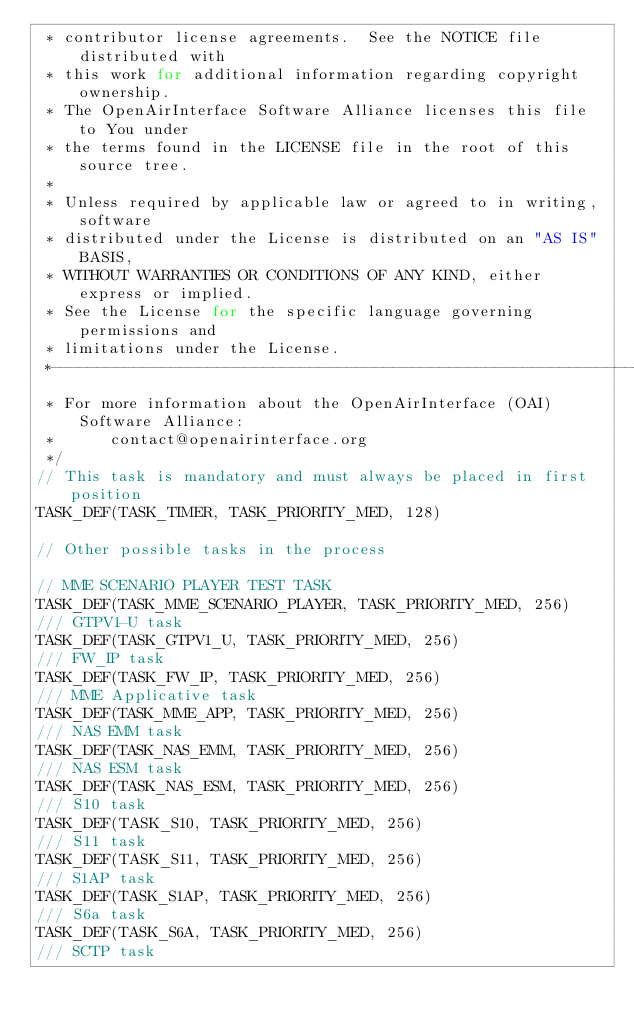<code> <loc_0><loc_0><loc_500><loc_500><_C_> * contributor license agreements.  See the NOTICE file distributed with
 * this work for additional information regarding copyright ownership.
 * The OpenAirInterface Software Alliance licenses this file to You under
 * the terms found in the LICENSE file in the root of this source tree.
 *
 * Unless required by applicable law or agreed to in writing, software
 * distributed under the License is distributed on an "AS IS" BASIS,
 * WITHOUT WARRANTIES OR CONDITIONS OF ANY KIND, either express or implied.
 * See the License for the specific language governing permissions and
 * limitations under the License.
 *-------------------------------------------------------------------------------
 * For more information about the OpenAirInterface (OAI) Software Alliance:
 *      contact@openairinterface.org
 */
// This task is mandatory and must always be placed in first position
TASK_DEF(TASK_TIMER, TASK_PRIORITY_MED, 128)

// Other possible tasks in the process

// MME SCENARIO PLAYER TEST TASK
TASK_DEF(TASK_MME_SCENARIO_PLAYER, TASK_PRIORITY_MED, 256)
/// GTPV1-U task
TASK_DEF(TASK_GTPV1_U, TASK_PRIORITY_MED, 256)
/// FW_IP task
TASK_DEF(TASK_FW_IP, TASK_PRIORITY_MED, 256)
/// MME Applicative task
TASK_DEF(TASK_MME_APP, TASK_PRIORITY_MED, 256)
/// NAS EMM task
TASK_DEF(TASK_NAS_EMM, TASK_PRIORITY_MED, 256)
/// NAS ESM task
TASK_DEF(TASK_NAS_ESM, TASK_PRIORITY_MED, 256)
/// S10 task
TASK_DEF(TASK_S10, TASK_PRIORITY_MED, 256)
/// S11 task
TASK_DEF(TASK_S11, TASK_PRIORITY_MED, 256)
/// S1AP task
TASK_DEF(TASK_S1AP, TASK_PRIORITY_MED, 256)
/// S6a task
TASK_DEF(TASK_S6A, TASK_PRIORITY_MED, 256)
/// SCTP task</code> 